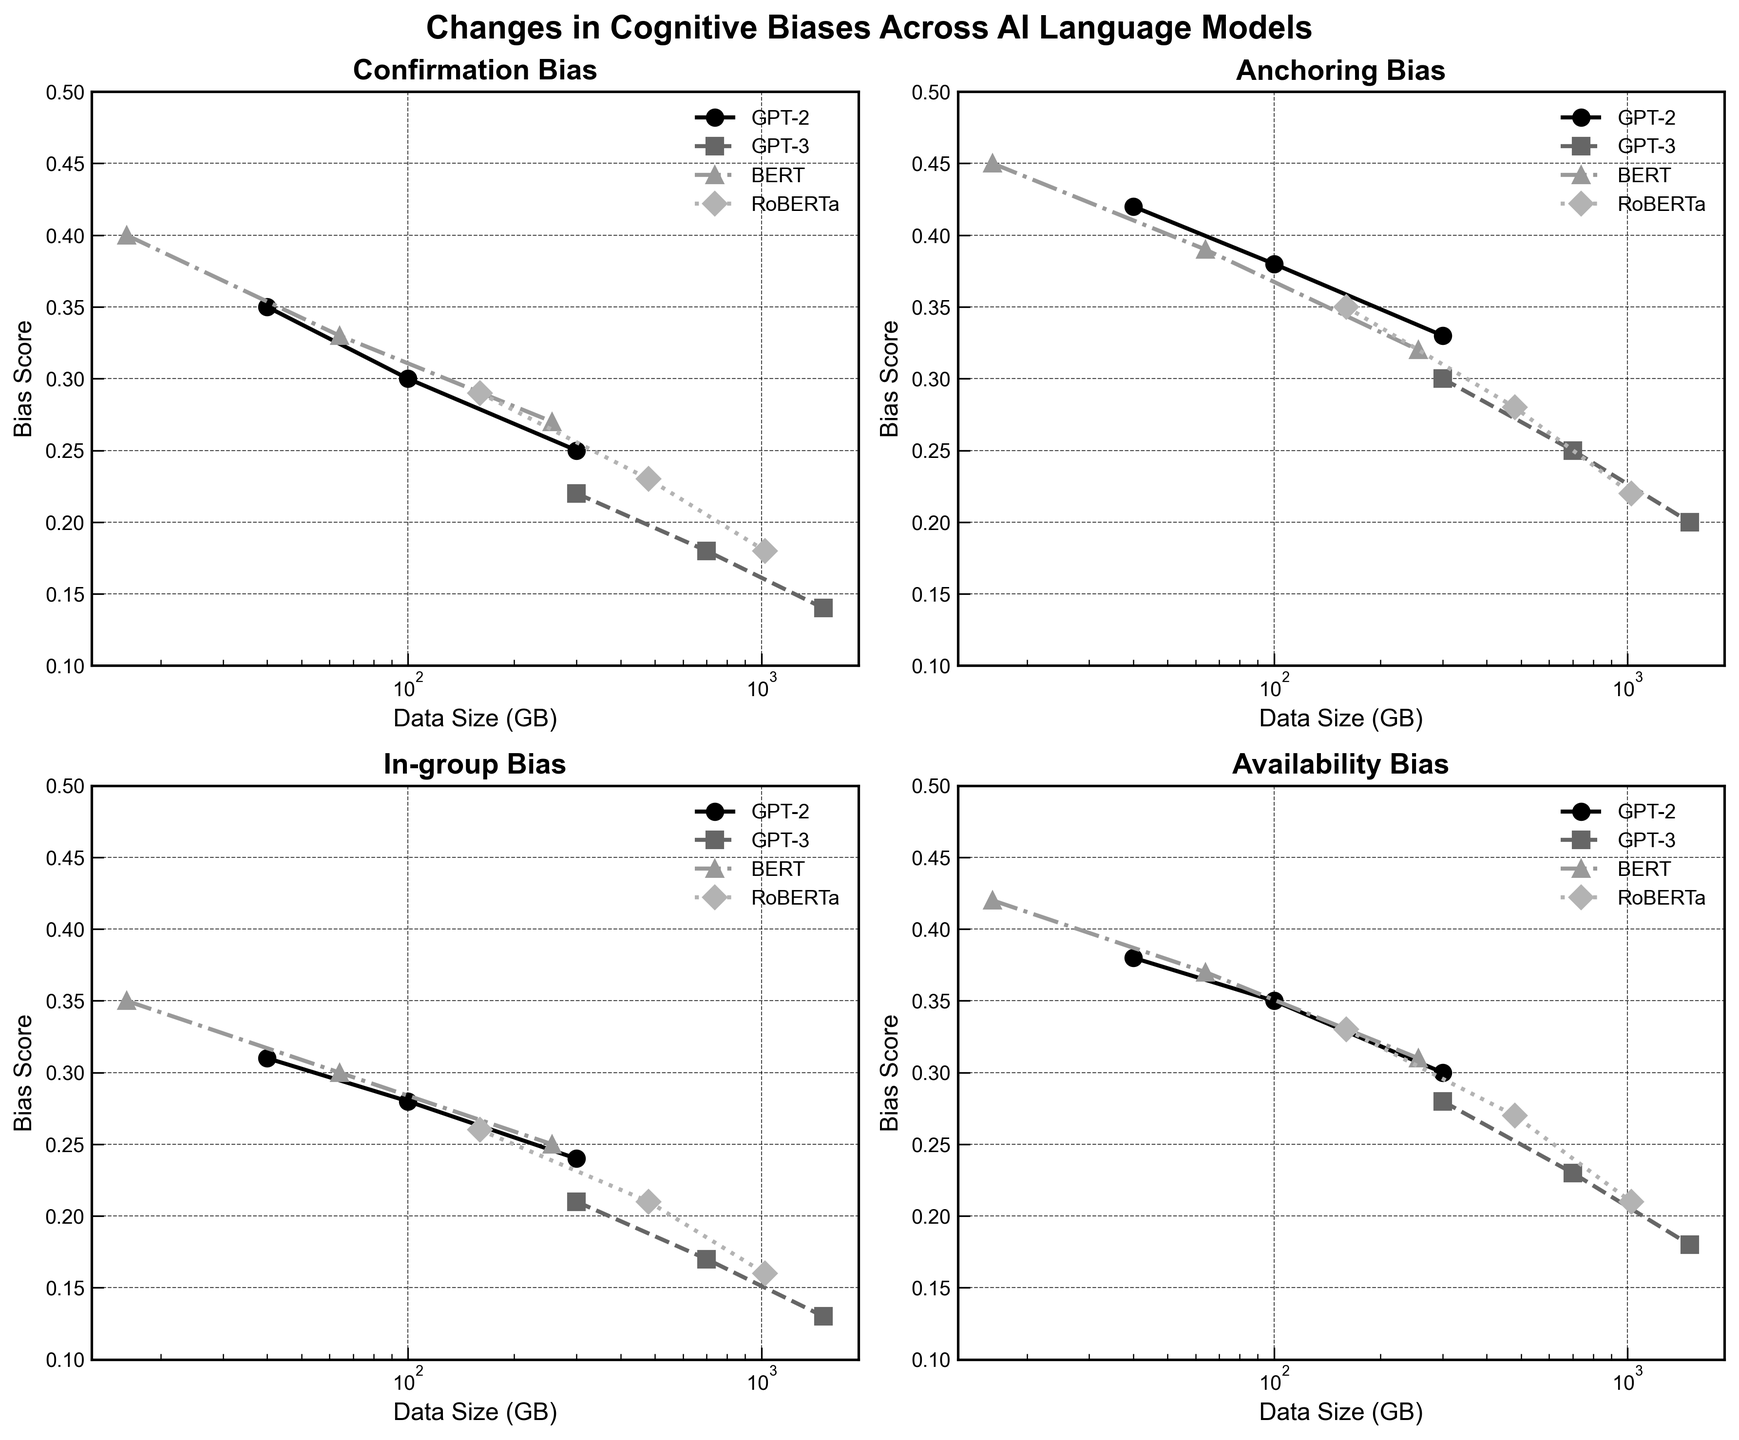What is the title of the figure? The title of the figure is displayed at the top in larger and bold text.
Answer: Changes in Cognitive Biases Across AI Language Models Which model has the highest Confirmation Bias at the smallest data size available? By looking at the Confirmation Bias subplot, locate the highest point for the smallest data size across all models. The highest value is from BERT at 16 GB.
Answer: BERT What happens to Anchoring Bias in GPT-3 as the data size increases from 300 GB to 1500 GB? In the Anchoring Bias subplot, trace the line for GPT-3 from 300 GB to 1500 GB and observe the trend. The bias decreases over this range.
Answer: Decreases Which cognitive bias showed the greatest decrease for GPT-2 from 40 GB to 300 GB? For GPT-2, compare the changes between 40 GB and 300 GB across all biases in their respective subplots. Confirmation Bias decreased from 0.35 to 0.25, which is the largest drop.
Answer: Confirmation Bias What is the range of Availability Bias scores for BERT across all data sizes? In the Availability Bias subplot, identify the highest and lowest values for BERT. They range from 0.42 to 0.31.
Answer: 0.31 to 0.42 Which model exhibits the smallest In-group Bias at the largest data size recorded? For the In-group Bias subplot, find the smallest value at the largest data size for each model. GPT-3 at 1500 GB shows the smallest bias of 0.13.
Answer: GPT-3 Is the relationship between data size and cognitive bias generally consistent across all models and biases? By analyzing all biases and models, observe the general trends. Across all biases, models consistently show a decrease in bias as data size increases.
Answer: Yes How does the Confirmation Bias score of RoBERTa at 480 GB compare to GPT-2 at 300 GB? In the Confirmation Bias subplot, find and compare the values: RoBERTa at 480 GB (0.23) and GPT-2 at 300 GB (0.25). RoBERTa has a lower bias at this point.
Answer: Lower Which bias showed the least change for GPT-3 from the smallest to the largest data size? Compare the changes in all four biases for GPT-3 from 300 GB to 1500 GB. The least change is in In-group Bias, decreasing from 0.21 to 0.13.
Answer: In-group Bias What is the general trend for cognitive biases in RoBERTa as data size increases? By observing all subplots for RoBERTa, the trend shows a consistent decrease in all cognitive biases as data size increases.
Answer: Decreasing 